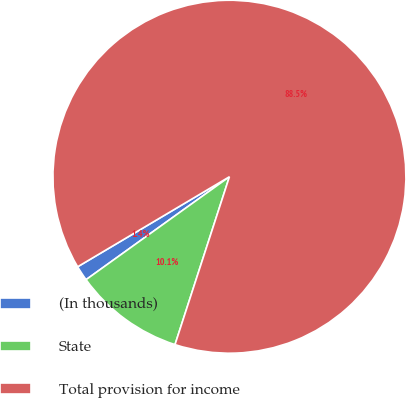<chart> <loc_0><loc_0><loc_500><loc_500><pie_chart><fcel>(In thousands)<fcel>State<fcel>Total provision for income<nl><fcel>1.39%<fcel>10.1%<fcel>88.51%<nl></chart> 